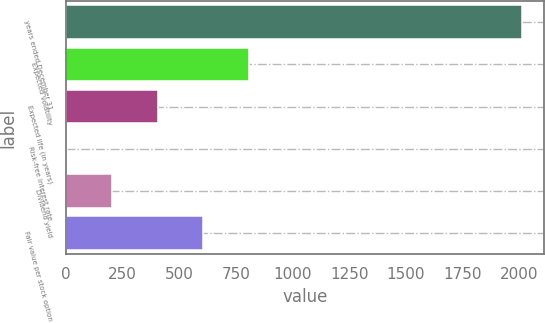Convert chart to OTSL. <chart><loc_0><loc_0><loc_500><loc_500><bar_chart><fcel>years ended December 31<fcel>Expected volatility<fcel>Expected life (in years)<fcel>Risk-free interest rate<fcel>Dividend yield<fcel>Fair value per stock option<nl><fcel>2011<fcel>805.72<fcel>403.96<fcel>2.2<fcel>203.08<fcel>604.84<nl></chart> 